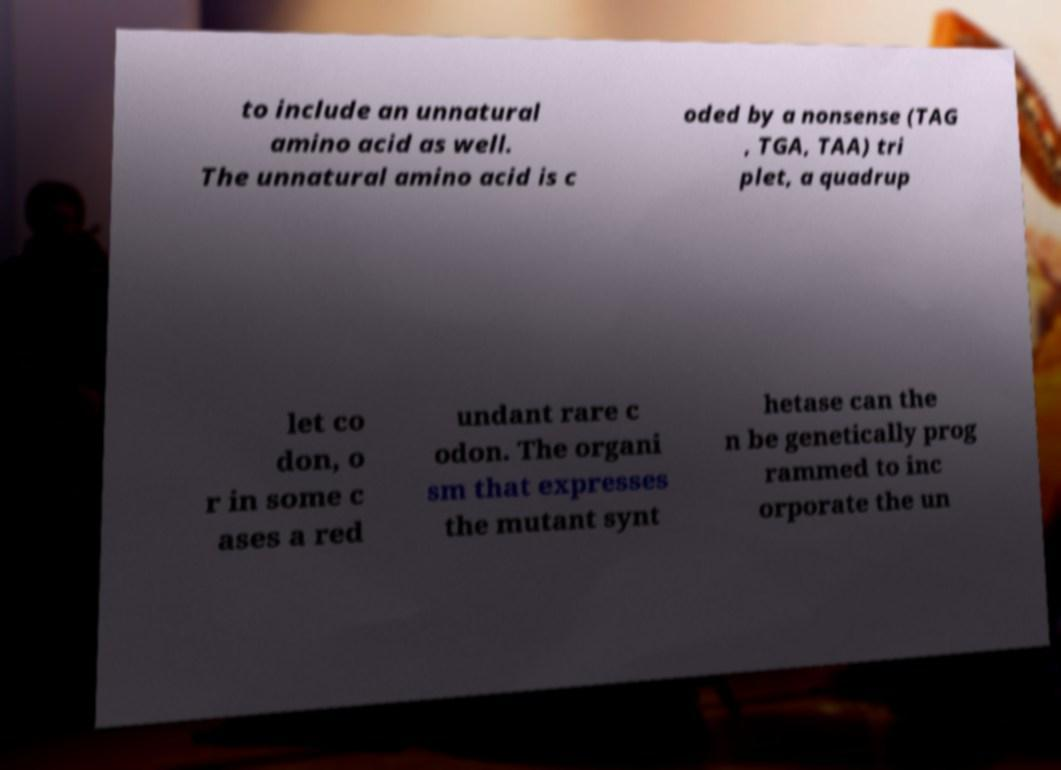There's text embedded in this image that I need extracted. Can you transcribe it verbatim? to include an unnatural amino acid as well. The unnatural amino acid is c oded by a nonsense (TAG , TGA, TAA) tri plet, a quadrup let co don, o r in some c ases a red undant rare c odon. The organi sm that expresses the mutant synt hetase can the n be genetically prog rammed to inc orporate the un 